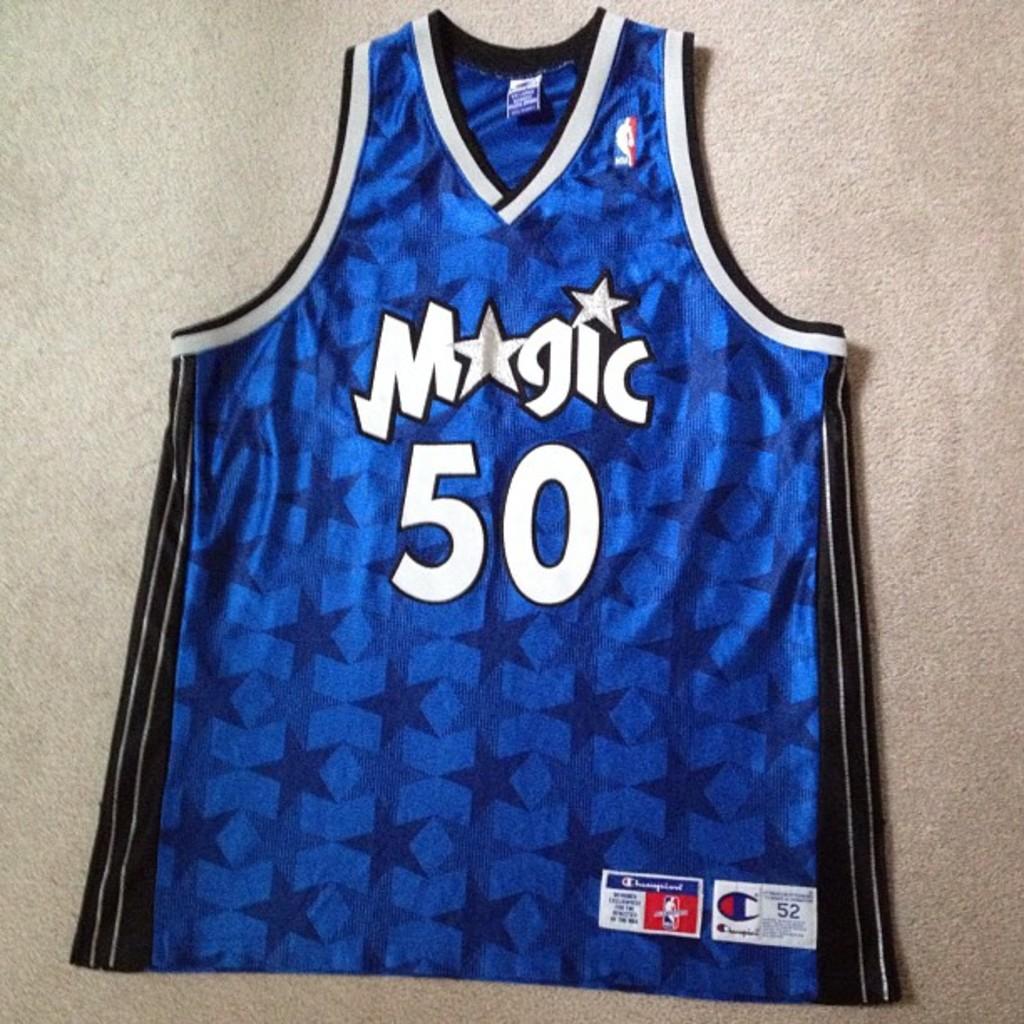What does it say above 50 on the jersey?
Your answer should be very brief. Magic. What number is this jersey?
Offer a terse response. 50. 